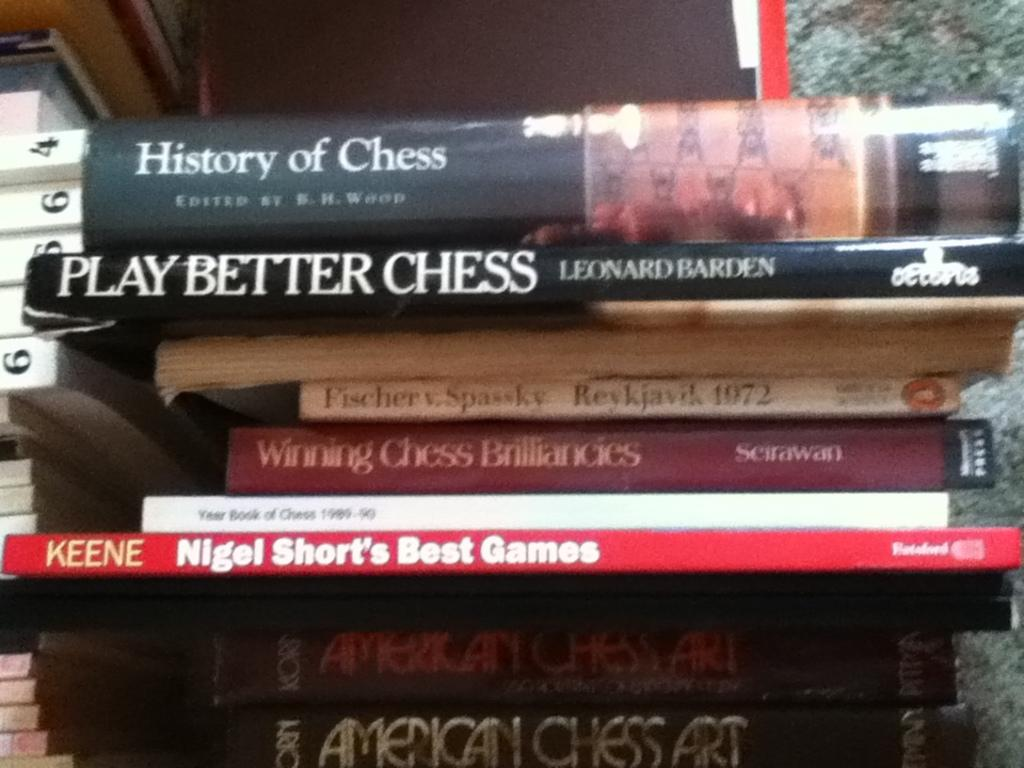<image>
Summarize the visual content of the image. A stack of books about chess including the History of Chess. 